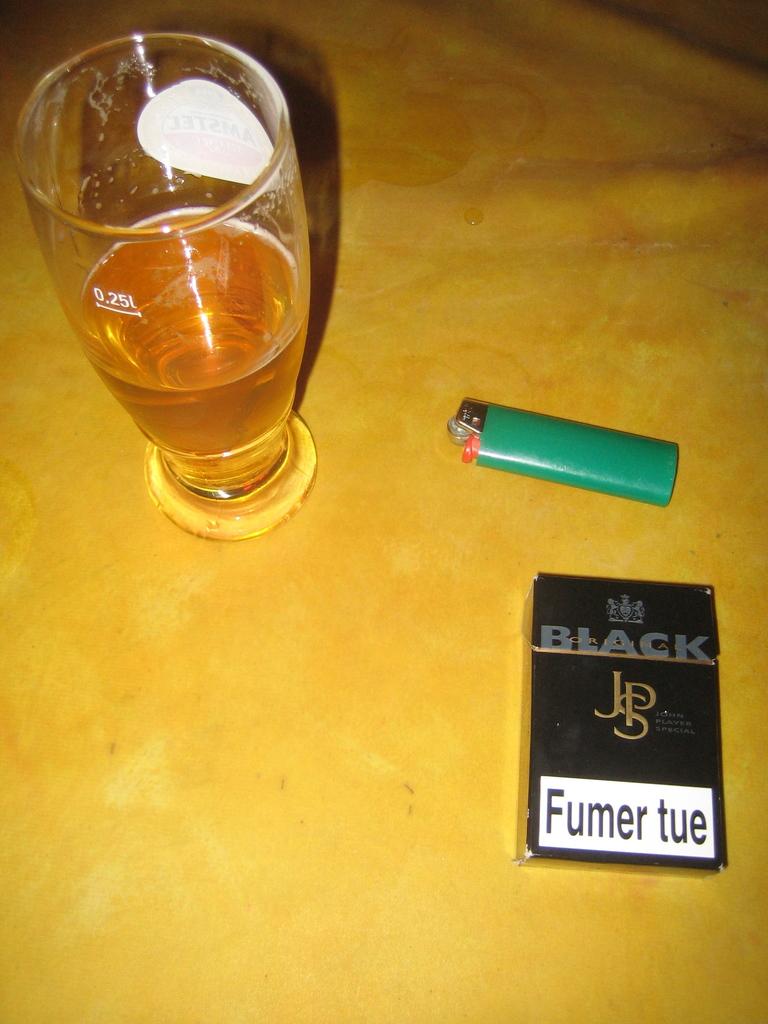What volume is there a measurement line on the glass for?
Keep it short and to the point. 0.25l. 